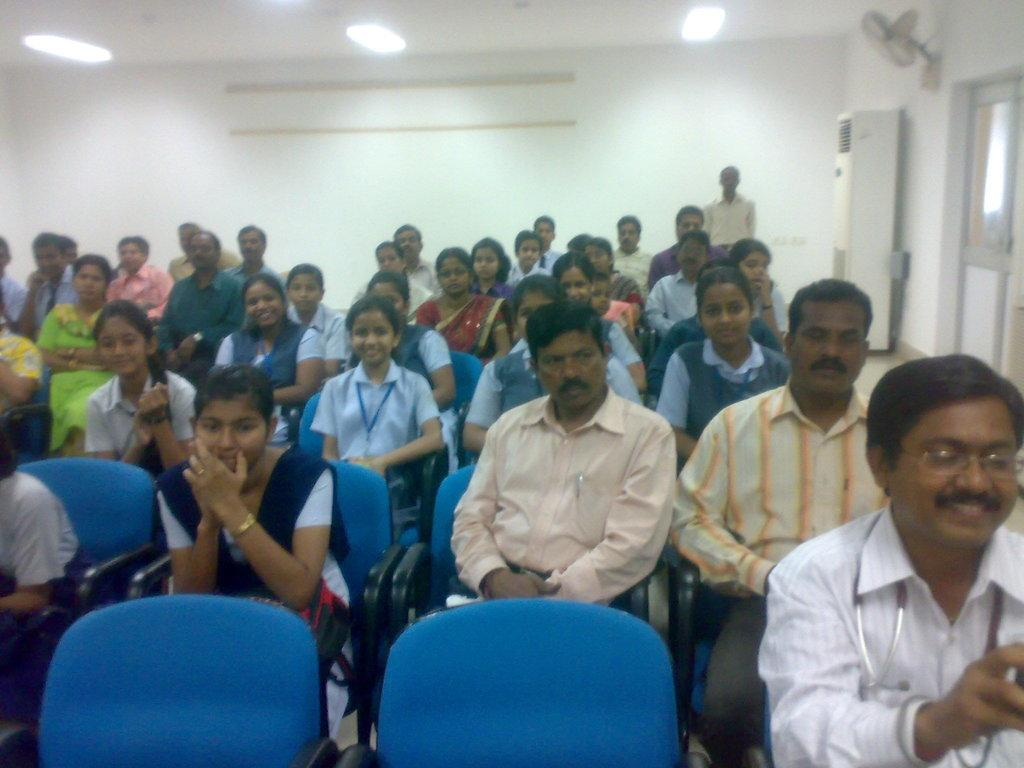How many people are in the image? There is a group of persons in the image. What are the persons doing in the image? The persons are sitting on a chair. Where does the scene take place? The image takes place in a room. What can be seen on the right side of the image? There is a cooler and a wall fan on the right side of the image. What type of nerve is visible in the image? There is no nerve visible in the image. Who created the cooler in the image? The image does not provide information about the creator of the cooler. 